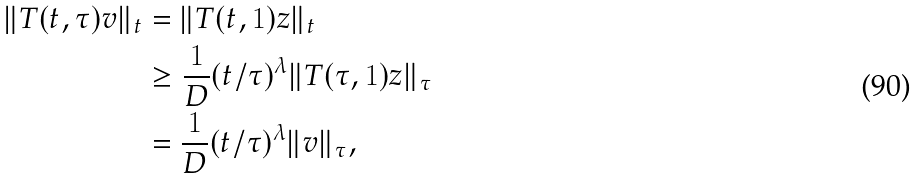<formula> <loc_0><loc_0><loc_500><loc_500>\| T ( t , \tau ) v \| _ { t } & = \| T ( t , 1 ) z \| _ { t } \\ & \geq \frac { 1 } { D } ( t / \tau ) ^ { \lambda } \| T ( \tau , 1 ) z \| _ { \tau } \\ & = \frac { 1 } { D } ( t / \tau ) ^ { \lambda } \| v \| _ { \tau } ,</formula> 